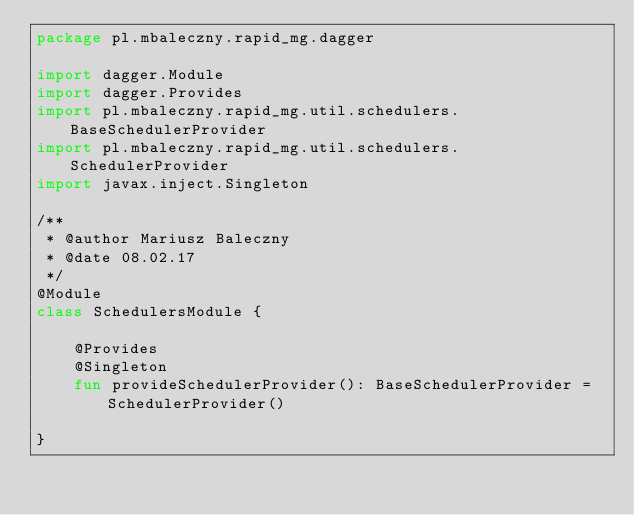Convert code to text. <code><loc_0><loc_0><loc_500><loc_500><_Kotlin_>package pl.mbaleczny.rapid_mg.dagger

import dagger.Module
import dagger.Provides
import pl.mbaleczny.rapid_mg.util.schedulers.BaseSchedulerProvider
import pl.mbaleczny.rapid_mg.util.schedulers.SchedulerProvider
import javax.inject.Singleton

/**
 * @author Mariusz Baleczny
 * @date 08.02.17
 */
@Module
class SchedulersModule {

    @Provides
    @Singleton
    fun provideSchedulerProvider(): BaseSchedulerProvider = SchedulerProvider()

}</code> 